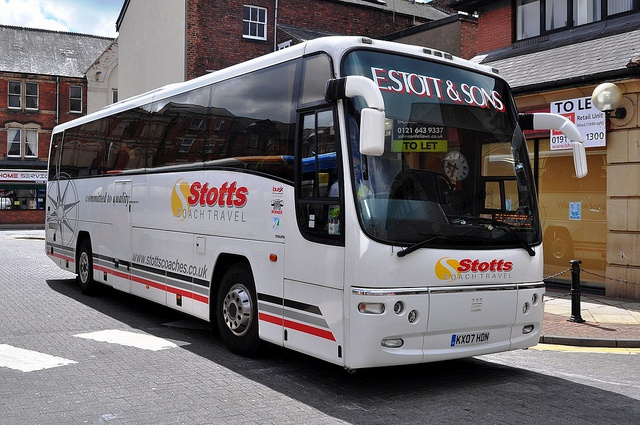Describe the objects in this image and their specific colors. I can see bus in white, black, darkgray, gray, and lightgray tones and clock in white, black, and gray tones in this image. 